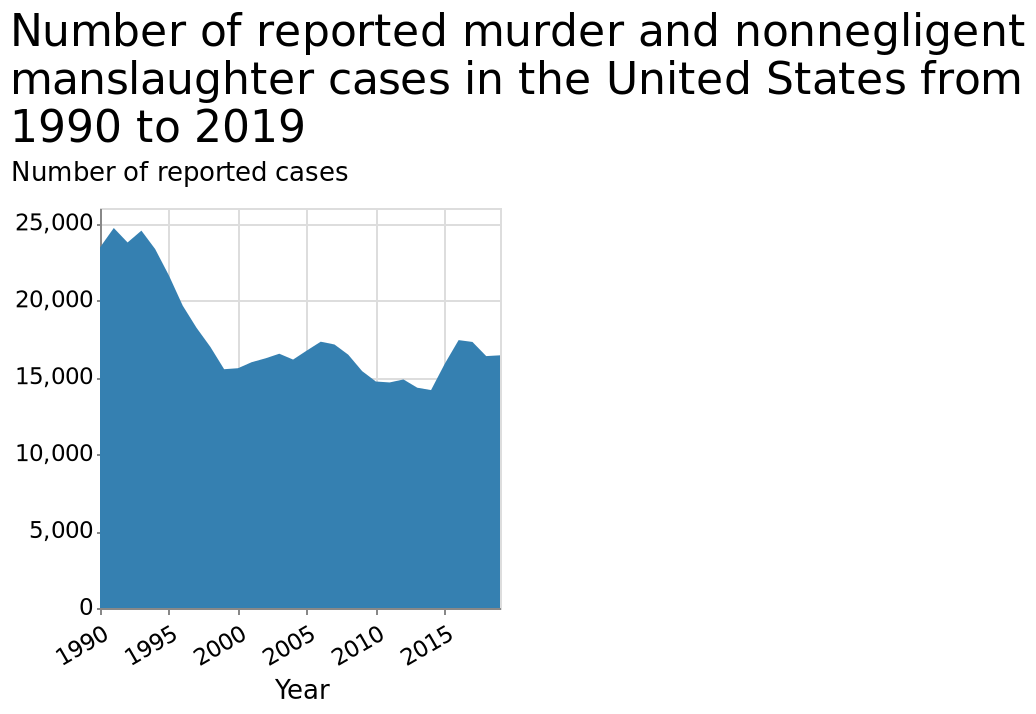<image>
please enumerates aspects of the construction of the chart Number of reported murder and nonnegligent manslaughter cases in the United States from 1990 to 2019 is a area chart. The y-axis shows Number of reported cases along linear scale of range 0 to 25,000 while the x-axis plots Year as linear scale of range 1990 to 2015. What is the range of the x-axis in the area chart? The range of the x-axis in the area chart is from 1990 to 2015. By how much did the number of reported murder and manslaughter cases increase around 2015? The number of reported murder and manslaughter cases increased around 2015 by about 3000. What is the overall decrease in reported murder and nonnegligent manslaughter cases from 1990 to 2019? The overall decrease in reported murder and nonnegligent manslaughter cases from 1990 to 2019 is approximately 9000. 